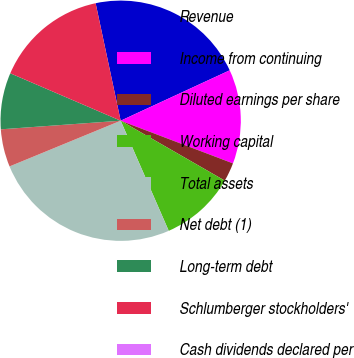Convert chart to OTSL. <chart><loc_0><loc_0><loc_500><loc_500><pie_chart><fcel>Revenue<fcel>Income from continuing<fcel>Diluted earnings per share<fcel>Working capital<fcel>Total assets<fcel>Net debt (1)<fcel>Long-term debt<fcel>Schlumberger stockholders'<fcel>Cash dividends declared per<nl><fcel>21.45%<fcel>12.67%<fcel>2.53%<fcel>10.14%<fcel>25.34%<fcel>5.07%<fcel>7.6%<fcel>15.2%<fcel>0.0%<nl></chart> 